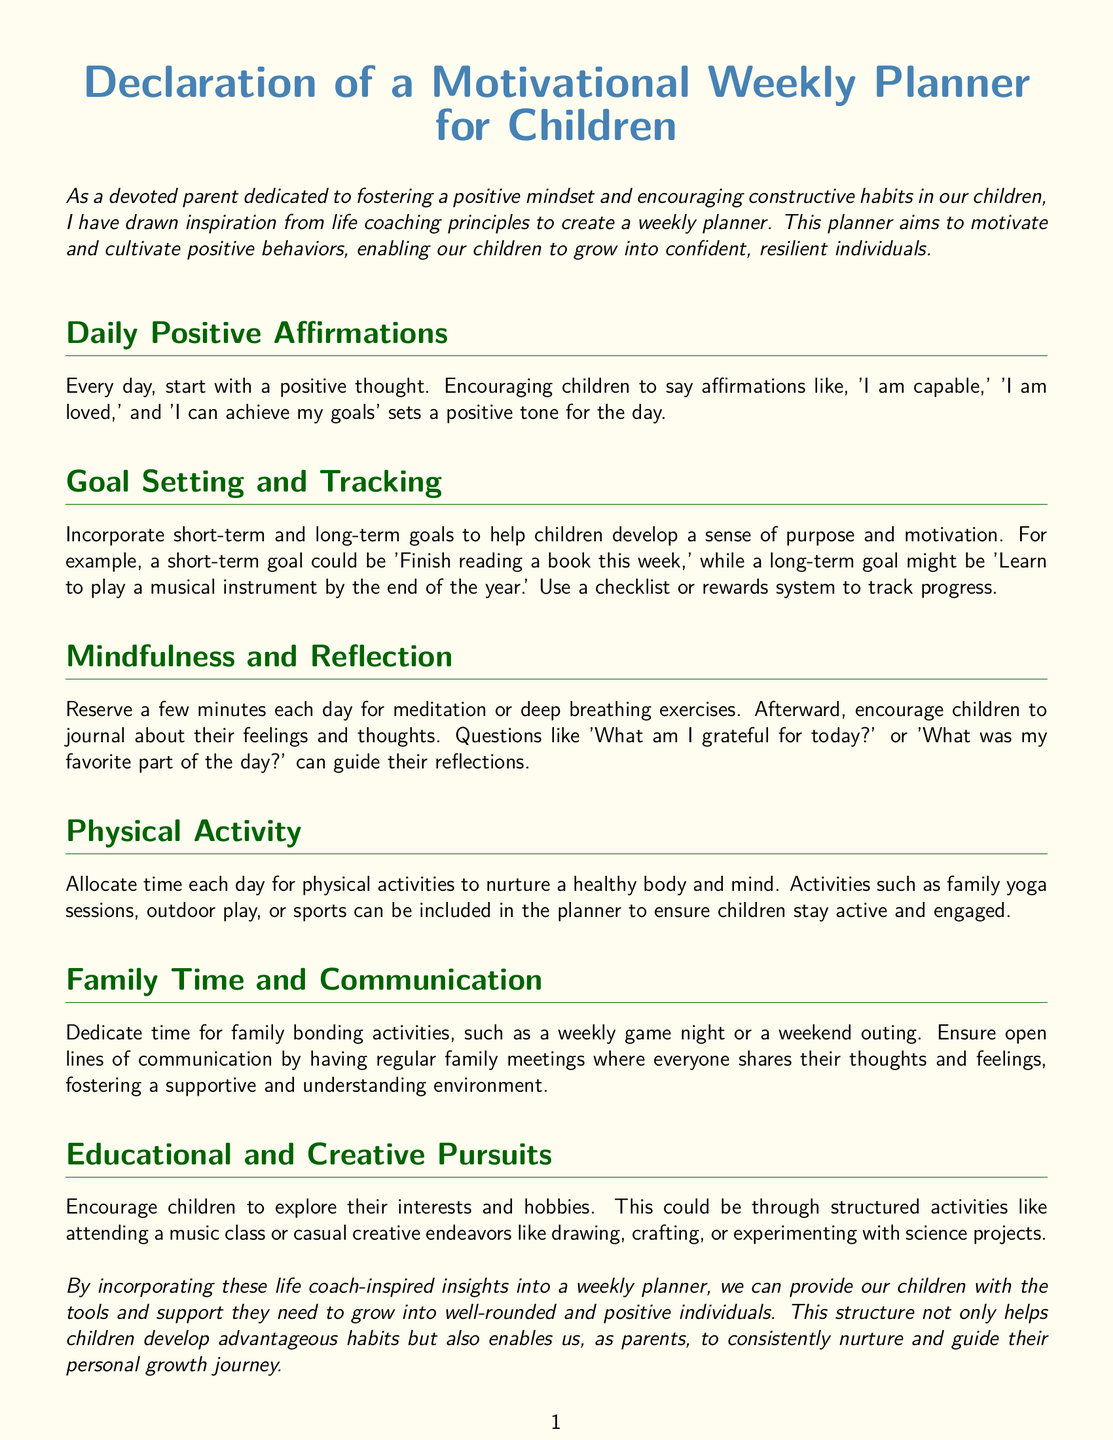what is the title of the document? The title of the document is clearly stated at the top, which is "Declaration of a Motivational Weekly Planner for Children."
Answer: Declaration of a Motivational Weekly Planner for Children what are daily positive affirmations meant to do? Daily positive affirmations are intended to set a positive tone for the day, encouraging children to think positively.
Answer: Set a positive tone name a short-term goal mentioned in the document. The document provides examples of goals, one being to "Finish reading a book this week."
Answer: Finish reading a book this week how often should mindfulness and reflection exercises occur? The text suggests reserving a few minutes each day for mindfulness and reflection exercises.
Answer: Each day what is one suggested physical activity mentioned? The document suggests family yoga sessions as one of the physical activities.
Answer: Family yoga sessions what is the purpose of the weekly planner? The purpose of the weekly planner is to provide tools and support for children to grow into well-rounded and positive individuals.
Answer: Foster positive habits 